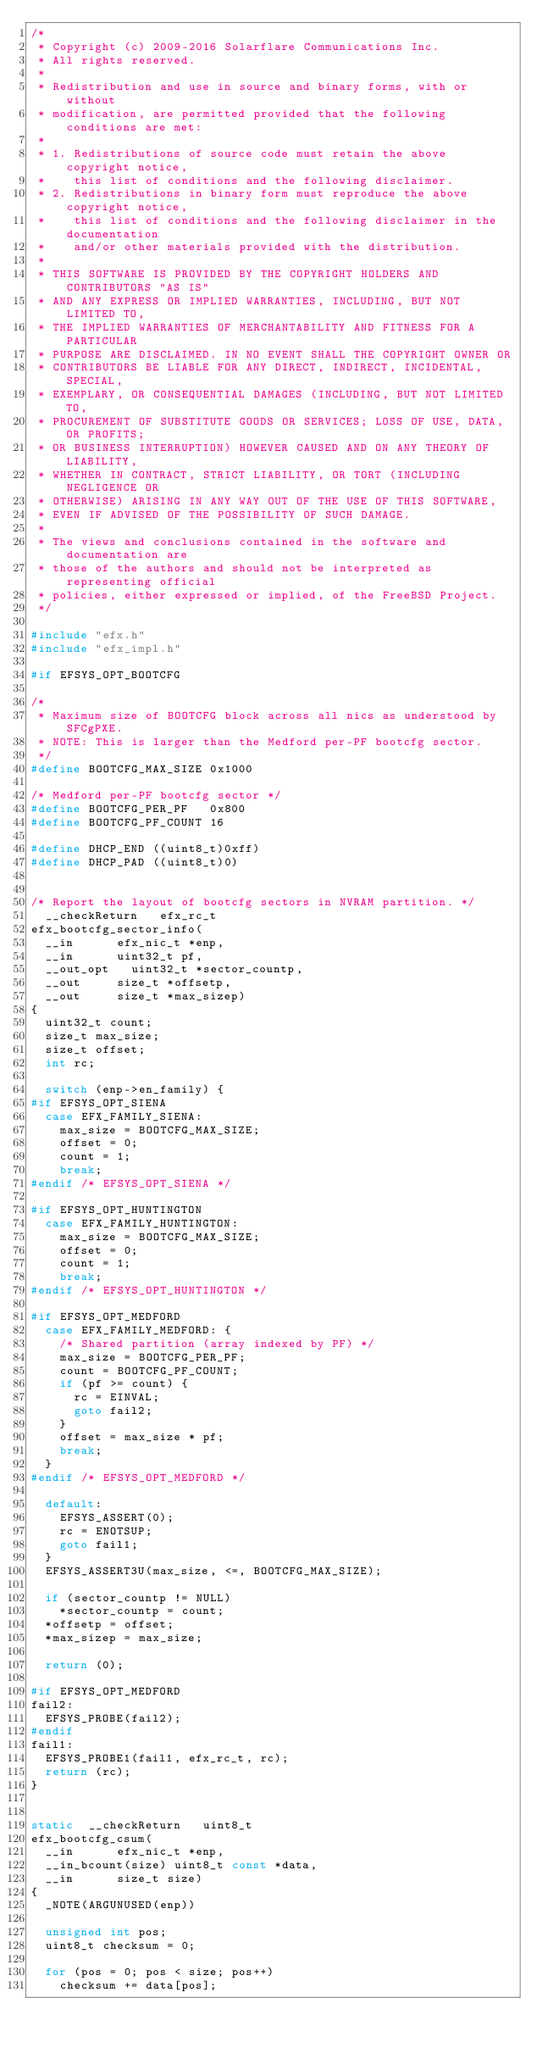Convert code to text. <code><loc_0><loc_0><loc_500><loc_500><_C_>/*
 * Copyright (c) 2009-2016 Solarflare Communications Inc.
 * All rights reserved.
 *
 * Redistribution and use in source and binary forms, with or without
 * modification, are permitted provided that the following conditions are met:
 *
 * 1. Redistributions of source code must retain the above copyright notice,
 *    this list of conditions and the following disclaimer.
 * 2. Redistributions in binary form must reproduce the above copyright notice,
 *    this list of conditions and the following disclaimer in the documentation
 *    and/or other materials provided with the distribution.
 *
 * THIS SOFTWARE IS PROVIDED BY THE COPYRIGHT HOLDERS AND CONTRIBUTORS "AS IS"
 * AND ANY EXPRESS OR IMPLIED WARRANTIES, INCLUDING, BUT NOT LIMITED TO,
 * THE IMPLIED WARRANTIES OF MERCHANTABILITY AND FITNESS FOR A PARTICULAR
 * PURPOSE ARE DISCLAIMED. IN NO EVENT SHALL THE COPYRIGHT OWNER OR
 * CONTRIBUTORS BE LIABLE FOR ANY DIRECT, INDIRECT, INCIDENTAL, SPECIAL,
 * EXEMPLARY, OR CONSEQUENTIAL DAMAGES (INCLUDING, BUT NOT LIMITED TO,
 * PROCUREMENT OF SUBSTITUTE GOODS OR SERVICES; LOSS OF USE, DATA, OR PROFITS;
 * OR BUSINESS INTERRUPTION) HOWEVER CAUSED AND ON ANY THEORY OF LIABILITY,
 * WHETHER IN CONTRACT, STRICT LIABILITY, OR TORT (INCLUDING NEGLIGENCE OR
 * OTHERWISE) ARISING IN ANY WAY OUT OF THE USE OF THIS SOFTWARE,
 * EVEN IF ADVISED OF THE POSSIBILITY OF SUCH DAMAGE.
 *
 * The views and conclusions contained in the software and documentation are
 * those of the authors and should not be interpreted as representing official
 * policies, either expressed or implied, of the FreeBSD Project.
 */

#include "efx.h"
#include "efx_impl.h"

#if EFSYS_OPT_BOOTCFG

/*
 * Maximum size of BOOTCFG block across all nics as understood by SFCgPXE.
 * NOTE: This is larger than the Medford per-PF bootcfg sector.
 */
#define	BOOTCFG_MAX_SIZE 0x1000

/* Medford per-PF bootcfg sector */
#define	BOOTCFG_PER_PF   0x800
#define	BOOTCFG_PF_COUNT 16

#define	DHCP_END ((uint8_t)0xff)
#define	DHCP_PAD ((uint8_t)0)


/* Report the layout of bootcfg sectors in NVRAM partition. */
	__checkReturn		efx_rc_t
efx_bootcfg_sector_info(
	__in			efx_nic_t *enp,
	__in			uint32_t pf,
	__out_opt		uint32_t *sector_countp,
	__out			size_t *offsetp,
	__out			size_t *max_sizep)
{
	uint32_t count;
	size_t max_size;
	size_t offset;
	int rc;

	switch (enp->en_family) {
#if EFSYS_OPT_SIENA
	case EFX_FAMILY_SIENA:
		max_size = BOOTCFG_MAX_SIZE;
		offset = 0;
		count = 1;
		break;
#endif /* EFSYS_OPT_SIENA */

#if EFSYS_OPT_HUNTINGTON
	case EFX_FAMILY_HUNTINGTON:
		max_size = BOOTCFG_MAX_SIZE;
		offset = 0;
		count = 1;
		break;
#endif /* EFSYS_OPT_HUNTINGTON */

#if EFSYS_OPT_MEDFORD
	case EFX_FAMILY_MEDFORD: {
		/* Shared partition (array indexed by PF) */
		max_size = BOOTCFG_PER_PF;
		count = BOOTCFG_PF_COUNT;
		if (pf >= count) {
			rc = EINVAL;
			goto fail2;
		}
		offset = max_size * pf;
		break;
	}
#endif /* EFSYS_OPT_MEDFORD */

	default:
		EFSYS_ASSERT(0);
		rc = ENOTSUP;
		goto fail1;
	}
	EFSYS_ASSERT3U(max_size, <=, BOOTCFG_MAX_SIZE);

	if (sector_countp != NULL)
		*sector_countp = count;
	*offsetp = offset;
	*max_sizep = max_size;

	return (0);

#if EFSYS_OPT_MEDFORD
fail2:
	EFSYS_PROBE(fail2);
#endif
fail1:
	EFSYS_PROBE1(fail1, efx_rc_t, rc);
	return (rc);
}


static	__checkReturn		uint8_t
efx_bootcfg_csum(
	__in			efx_nic_t *enp,
	__in_bcount(size)	uint8_t const *data,
	__in			size_t size)
{
	_NOTE(ARGUNUSED(enp))

	unsigned int pos;
	uint8_t checksum = 0;

	for (pos = 0; pos < size; pos++)
		checksum += data[pos];</code> 